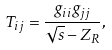Convert formula to latex. <formula><loc_0><loc_0><loc_500><loc_500>T _ { i j } = \frac { g _ { i i } g _ { j j } } { \sqrt { s } - Z _ { R } } ,</formula> 